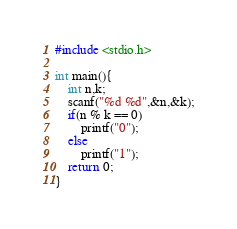Convert code to text. <code><loc_0><loc_0><loc_500><loc_500><_C_>#include <stdio.h>

int main(){
	int n,k;
	scanf("%d %d",&n,&k);
	if(n % k == 0)
		printf("0");
	else
		printf("1");
	return 0;
}</code> 